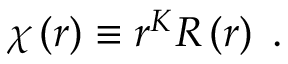<formula> <loc_0><loc_0><loc_500><loc_500>\chi \left ( r \right ) \equiv r ^ { K } R \left ( r \right ) \, .</formula> 